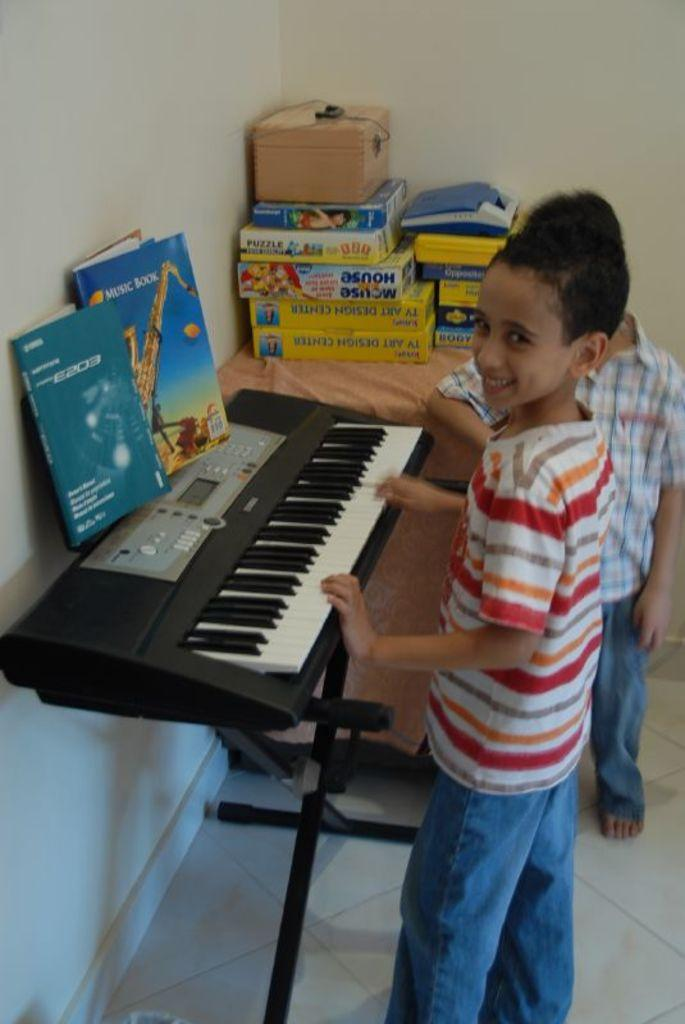How many boys are present in the image? There are two boys standing in the image. What is in front of the boys? There is a piano and books in front of the boys. Can you describe any other objects in the image? Yes, there is a box in the image. What type of paste is being used by the boys to play the piano in the image? There is no paste present in the image, and the boys are not using any paste to play the piano. 